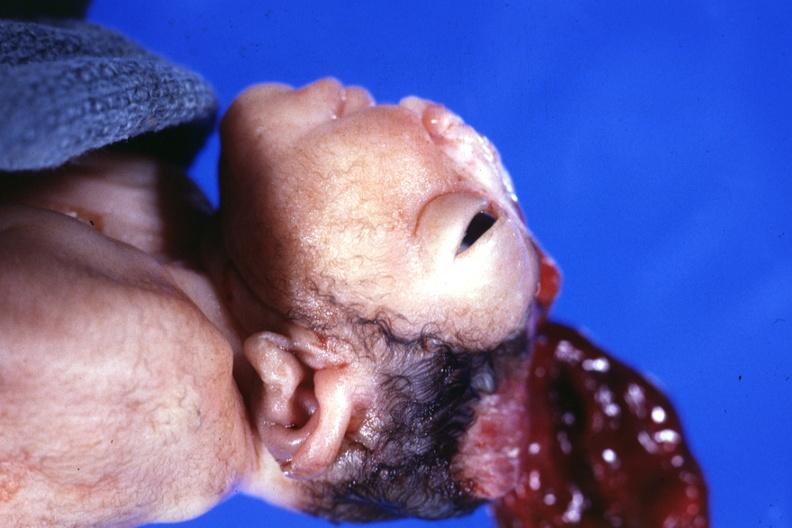what does this image show?
Answer the question using a single word or phrase. Lateral view close-up typical 